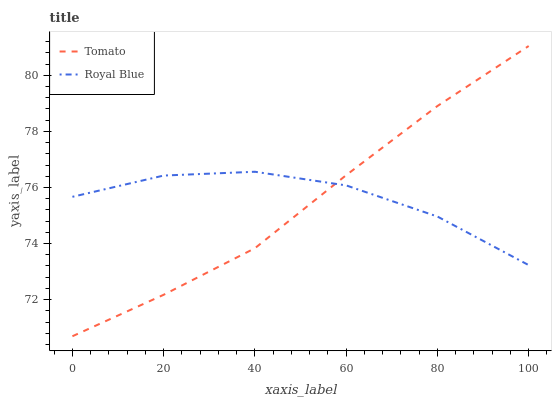Does Tomato have the minimum area under the curve?
Answer yes or no. Yes. Does Royal Blue have the maximum area under the curve?
Answer yes or no. Yes. Does Royal Blue have the minimum area under the curve?
Answer yes or no. No. Is Tomato the smoothest?
Answer yes or no. Yes. Is Royal Blue the roughest?
Answer yes or no. Yes. Is Royal Blue the smoothest?
Answer yes or no. No. Does Royal Blue have the lowest value?
Answer yes or no. No. Does Tomato have the highest value?
Answer yes or no. Yes. Does Royal Blue have the highest value?
Answer yes or no. No. Does Tomato intersect Royal Blue?
Answer yes or no. Yes. Is Tomato less than Royal Blue?
Answer yes or no. No. Is Tomato greater than Royal Blue?
Answer yes or no. No. 